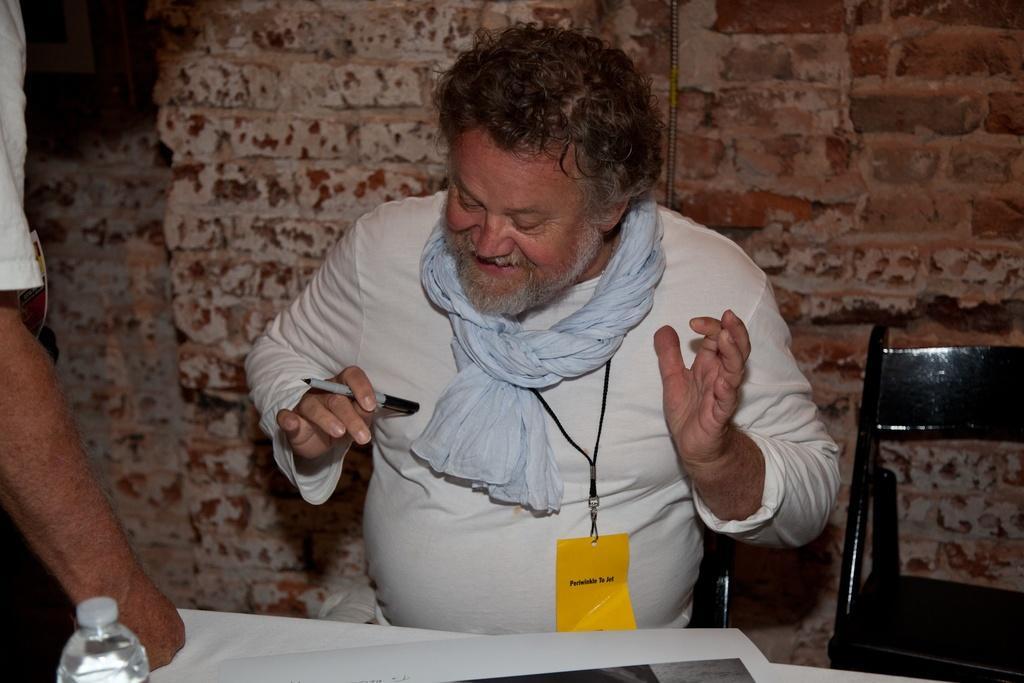Can you describe this image briefly? In this image there is a person sitting on the chair and he is holding the pen. Beside him there is a chair. In front of him there is a table. On top of it there is a water bottle. There is a paper. Behind him there is a wall. On the left side of the image there is a person. 